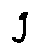Convert formula to latex. <formula><loc_0><loc_0><loc_500><loc_500>g</formula> 